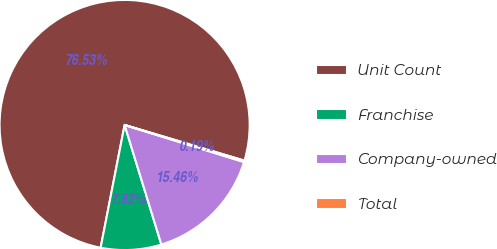Convert chart to OTSL. <chart><loc_0><loc_0><loc_500><loc_500><pie_chart><fcel>Unit Count<fcel>Franchise<fcel>Company-owned<fcel>Total<nl><fcel>76.53%<fcel>7.82%<fcel>15.46%<fcel>0.19%<nl></chart> 